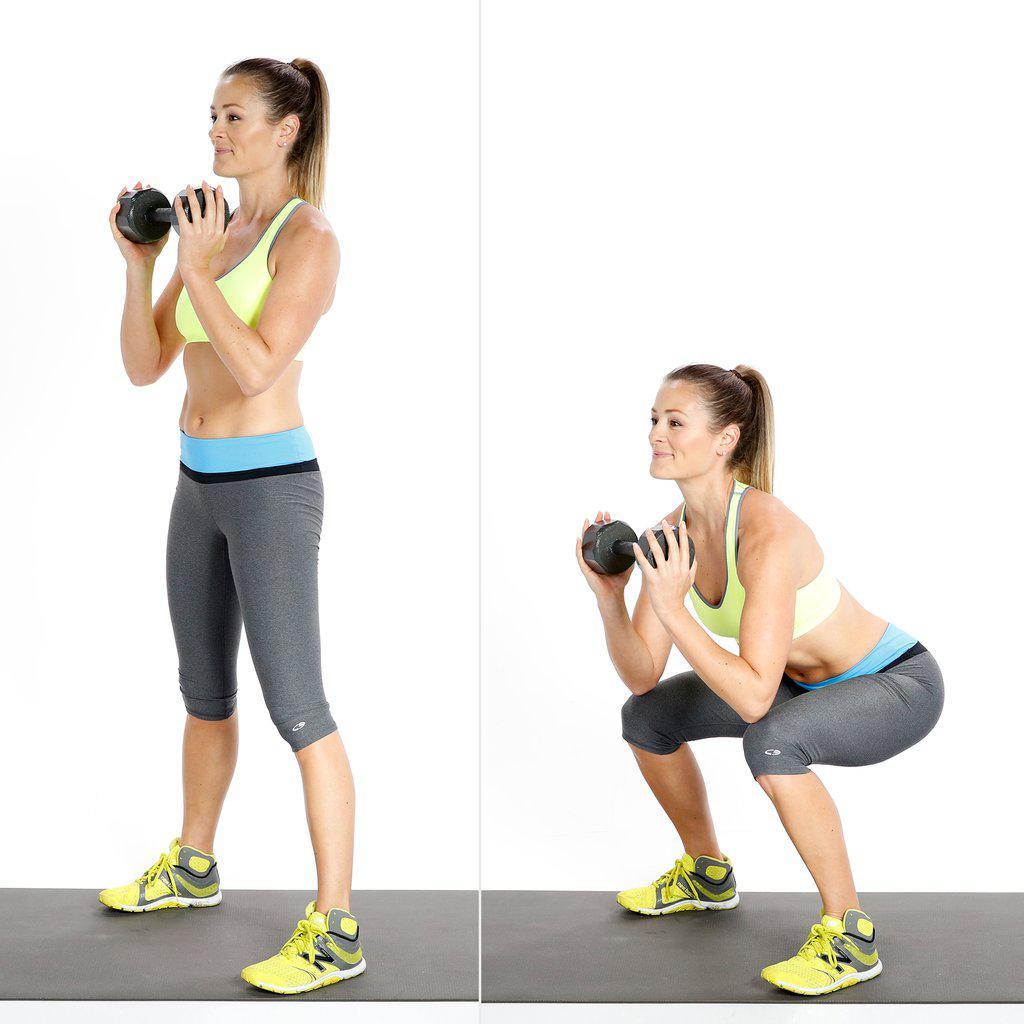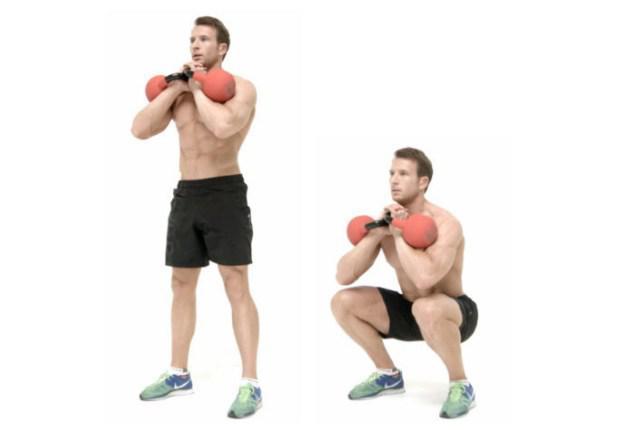The first image is the image on the left, the second image is the image on the right. Considering the images on both sides, is "The left and right image contains the same number of  people working out with weights." valid? Answer yes or no. Yes. The first image is the image on the left, the second image is the image on the right. Analyze the images presented: Is the assertion "Each image shows two steps of a weight workout, with a standing pose on the left and a crouched pose next to it." valid? Answer yes or no. Yes. 